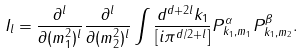Convert formula to latex. <formula><loc_0><loc_0><loc_500><loc_500>I _ { l } = \frac { \partial ^ { l } } { \partial ( m _ { 1 } ^ { 2 } ) ^ { l } } \frac { \partial ^ { l } } { \partial ( m _ { 2 } ^ { 2 } ) ^ { l } } \int \frac { d ^ { d + 2 l } k _ { 1 } } { [ i \pi ^ { d / 2 + l } ] } P _ { k _ { 1 } , m _ { 1 } } ^ { \alpha } P _ { k _ { 1 } , m _ { 2 } } ^ { \beta } .</formula> 